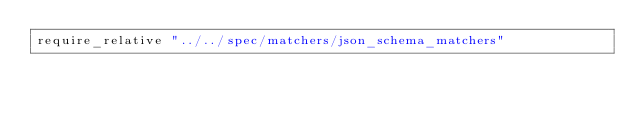<code> <loc_0><loc_0><loc_500><loc_500><_Ruby_>require_relative "../../spec/matchers/json_schema_matchers"
</code> 